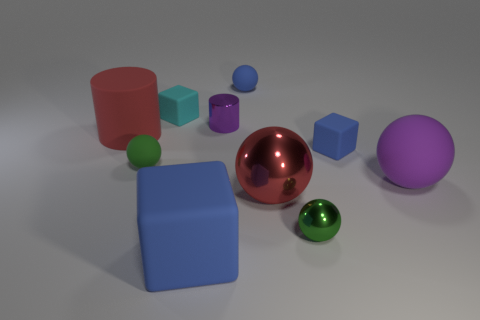Subtract all blue matte spheres. How many spheres are left? 4 Subtract all blue spheres. How many spheres are left? 4 Subtract all cyan balls. Subtract all cyan cylinders. How many balls are left? 5 Subtract all cylinders. How many objects are left? 8 Subtract all blue balls. Subtract all small blue rubber cylinders. How many objects are left? 9 Add 8 small matte cubes. How many small matte cubes are left? 10 Add 7 purple shiny cylinders. How many purple shiny cylinders exist? 8 Subtract 0 green cylinders. How many objects are left? 10 